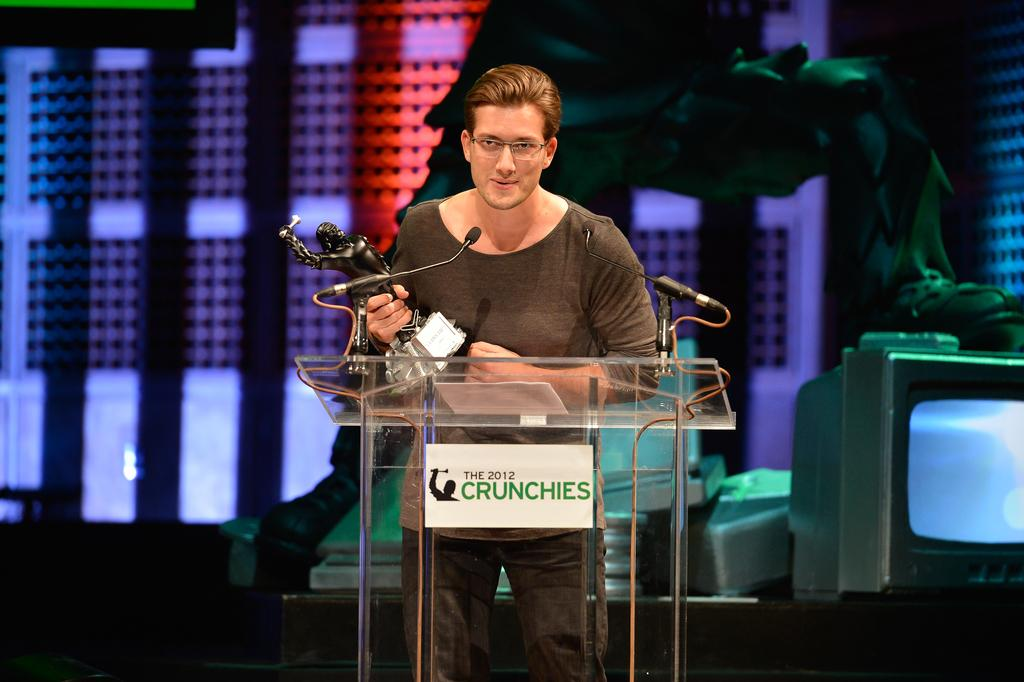<image>
Relay a brief, clear account of the picture shown. A person holds a trophy behind a podium for The 2012 Crunchies. 